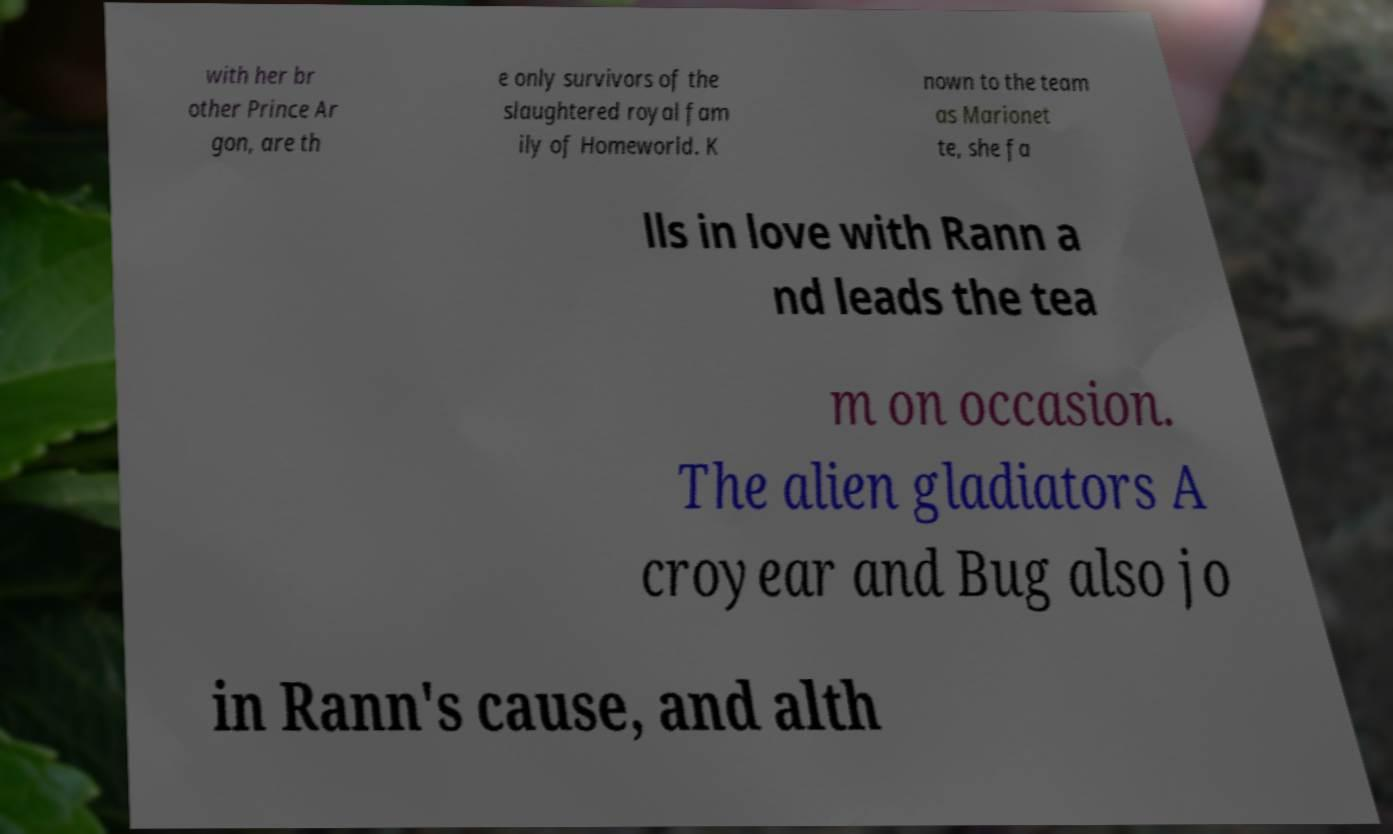Please identify and transcribe the text found in this image. with her br other Prince Ar gon, are th e only survivors of the slaughtered royal fam ily of Homeworld. K nown to the team as Marionet te, she fa lls in love with Rann a nd leads the tea m on occasion. The alien gladiators A croyear and Bug also jo in Rann's cause, and alth 